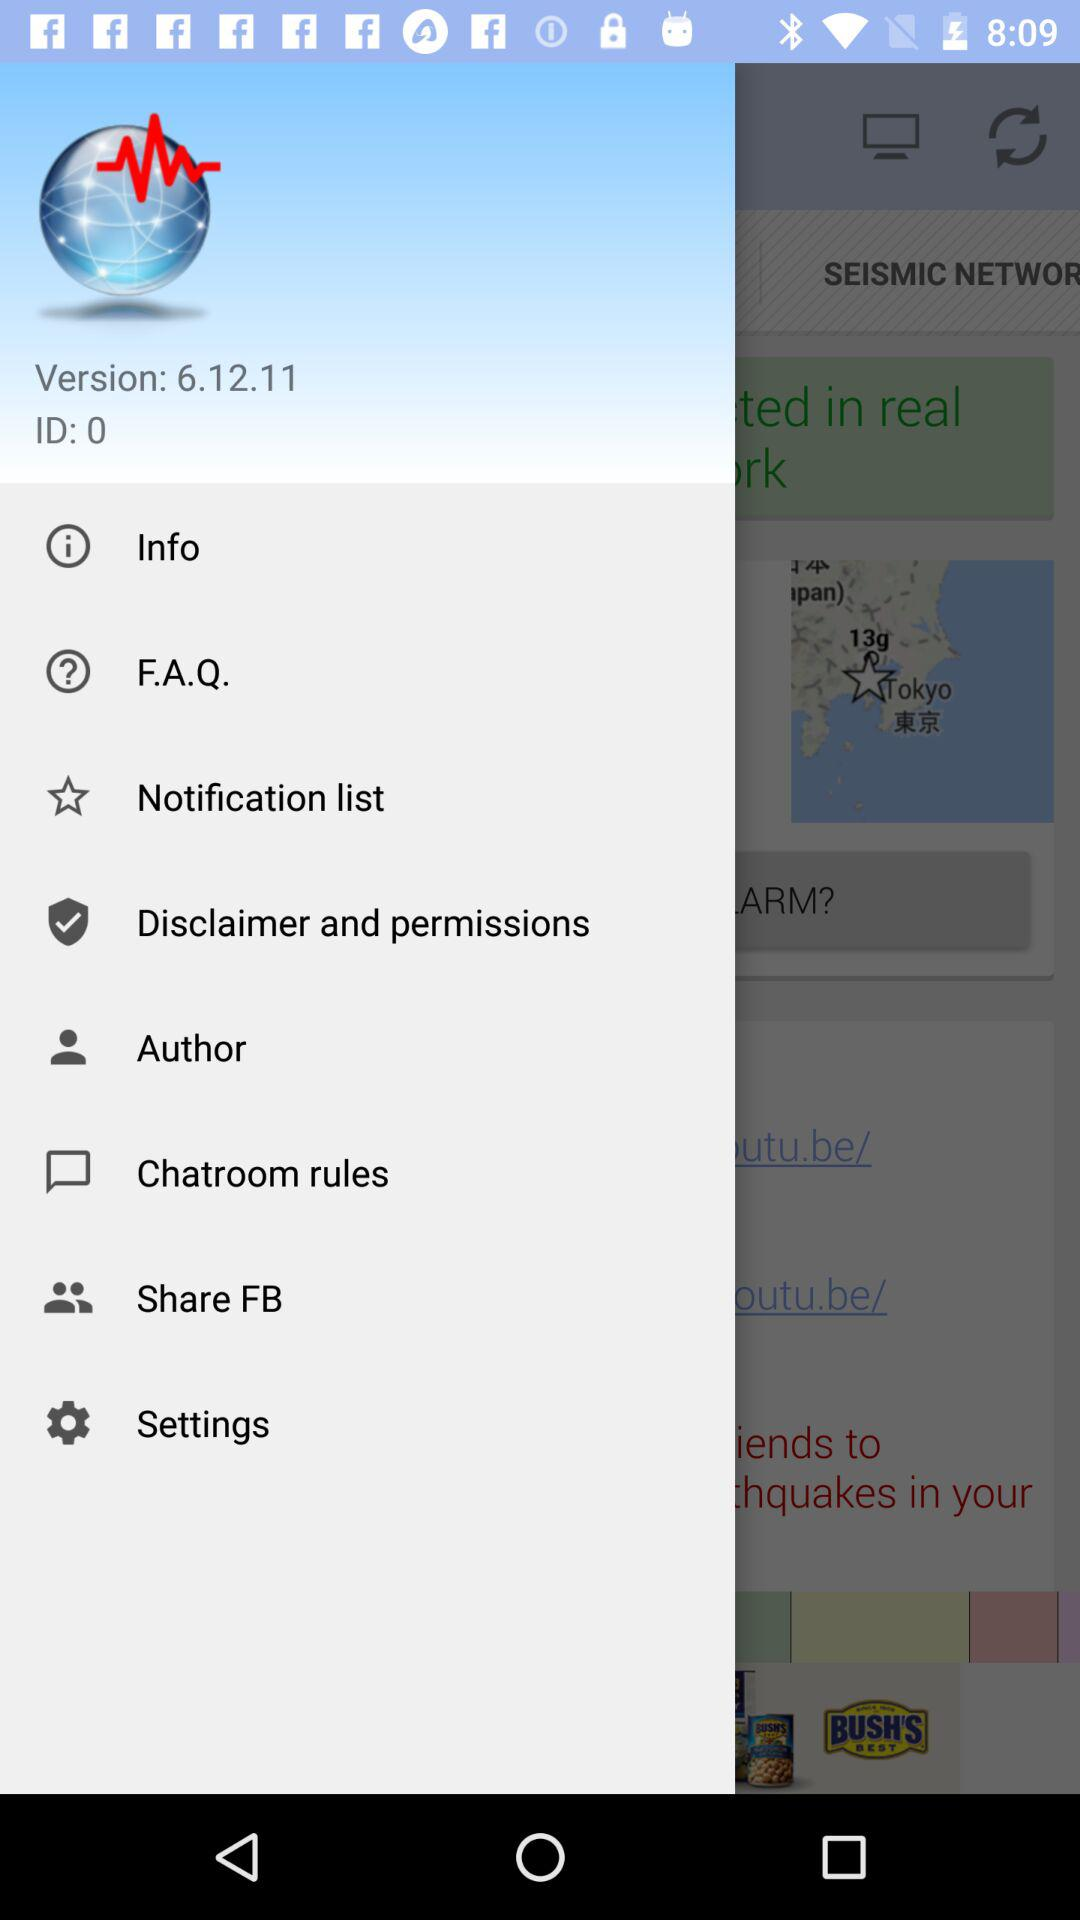Which questions are the most frequently asked?
When the provided information is insufficient, respond with <no answer>. <no answer> 